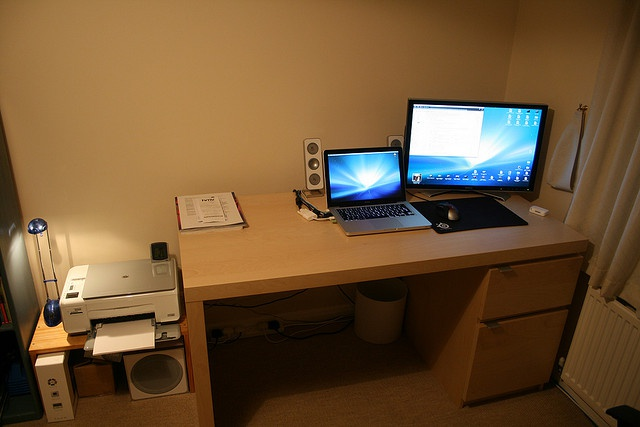Describe the objects in this image and their specific colors. I can see tv in olive, white, black, and lightblue tones, laptop in olive, black, gray, and lightblue tones, book in olive, tan, gray, and maroon tones, and mouse in olive, black, maroon, and gray tones in this image. 